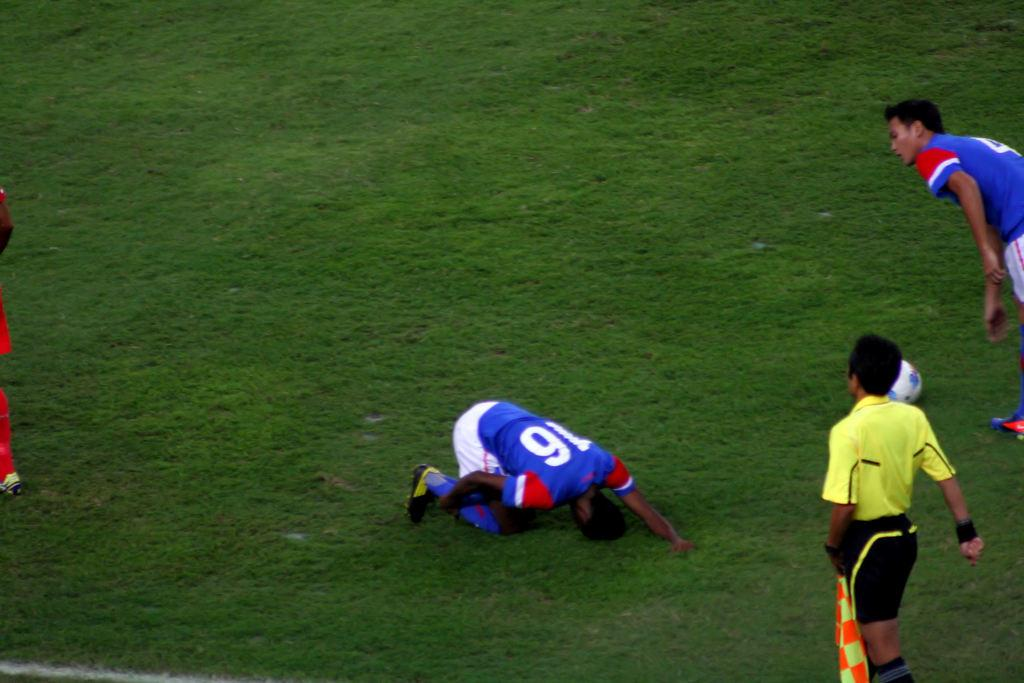What is the surface that the people are standing on in the image? The ground is covered with grass. What activity might the people be engaged in, given the presence of a football on the ground? The people might be playing football or watching a game. Can you describe the type of terrain in the image? The terrain is grassy, as the ground is covered with grass. What type of appliance can be seen plugged into the ground in the image? There is no appliance plugged into the ground in the image; it features people standing on grass with a football. How much debt is visible in the image? There is no mention of debt in the image; it focuses on people and a football on a grassy surface. 